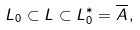<formula> <loc_0><loc_0><loc_500><loc_500>L _ { 0 } \subset L \subset L _ { 0 } ^ { * } = \overline { A } \, ,</formula> 